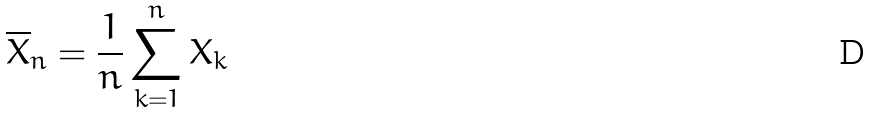<formula> <loc_0><loc_0><loc_500><loc_500>\overline { X } _ { n } = \frac { 1 } { n } \sum _ { k = 1 } ^ { n } X _ { k }</formula> 